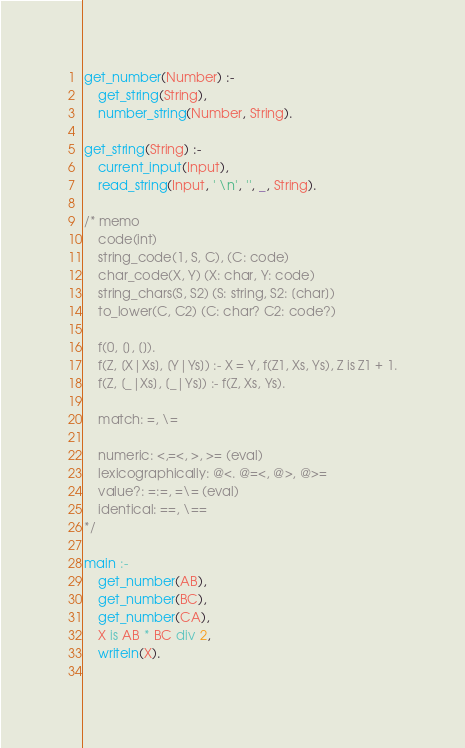Convert code to text. <code><loc_0><loc_0><loc_500><loc_500><_Prolog_>get_number(Number) :-
    get_string(String),
    number_string(Number, String).

get_string(String) :-
    current_input(Input),
    read_string(Input, ' \n', '', _, String).

/* memo
    code(int)
    string_code(1, S, C), (C: code)
    char_code(X, Y) (X: char, Y: code)
    string_chars(S, S2) (S: string, S2: [char])
    to_lower(C, C2) (C: char? C2: code?)

    f(0, [], []).
    f(Z, [X|Xs], [Y|Ys]) :- X = Y, f(Z1, Xs, Ys), Z is Z1 + 1.
    f(Z, [_|Xs], [_|Ys]) :- f(Z, Xs, Ys).

    match: =, \=

    numeric: <,=<, >, >= (eval)
    lexicographically: @<. @=<, @>, @>=
    value?: =:=, =\= (eval)
    identical: ==, \==
*/

main :-
    get_number(AB),
    get_number(BC),
    get_number(CA),
    X is AB * BC div 2,
    writeln(X).
 </code> 